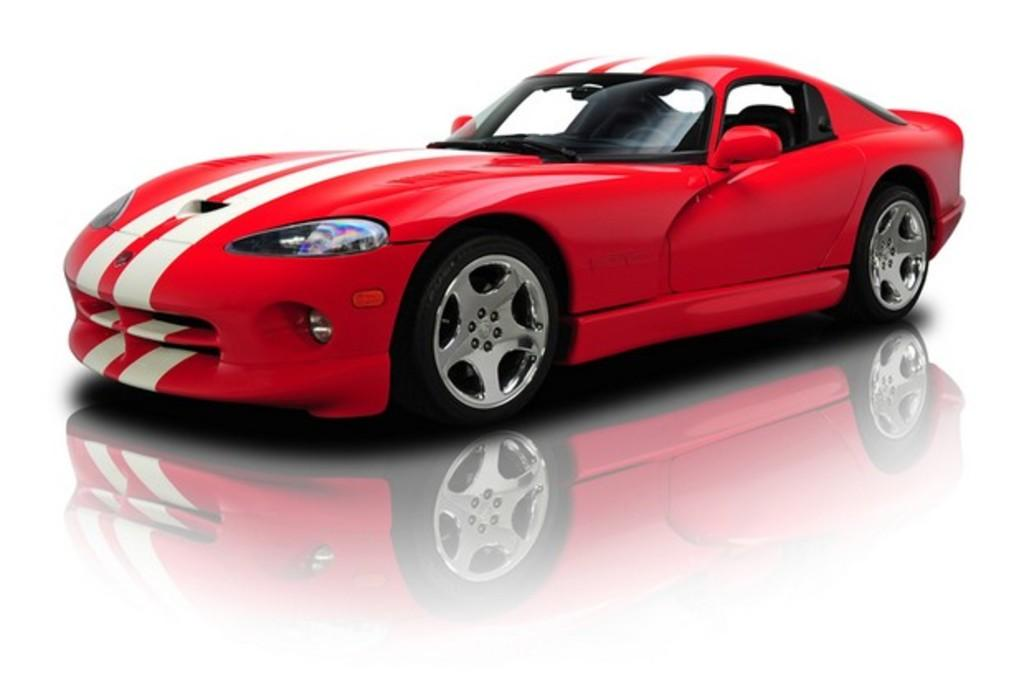What is the main subject of the image? The main subject of the image is a car. Can you describe the colors of the car? The car has red, white, and black colors. What is the color of the background in the image? The background of the image is white. Are there any bears eating lunch in the image? No, there are no bears or any lunch-related activities depicted in the image. 